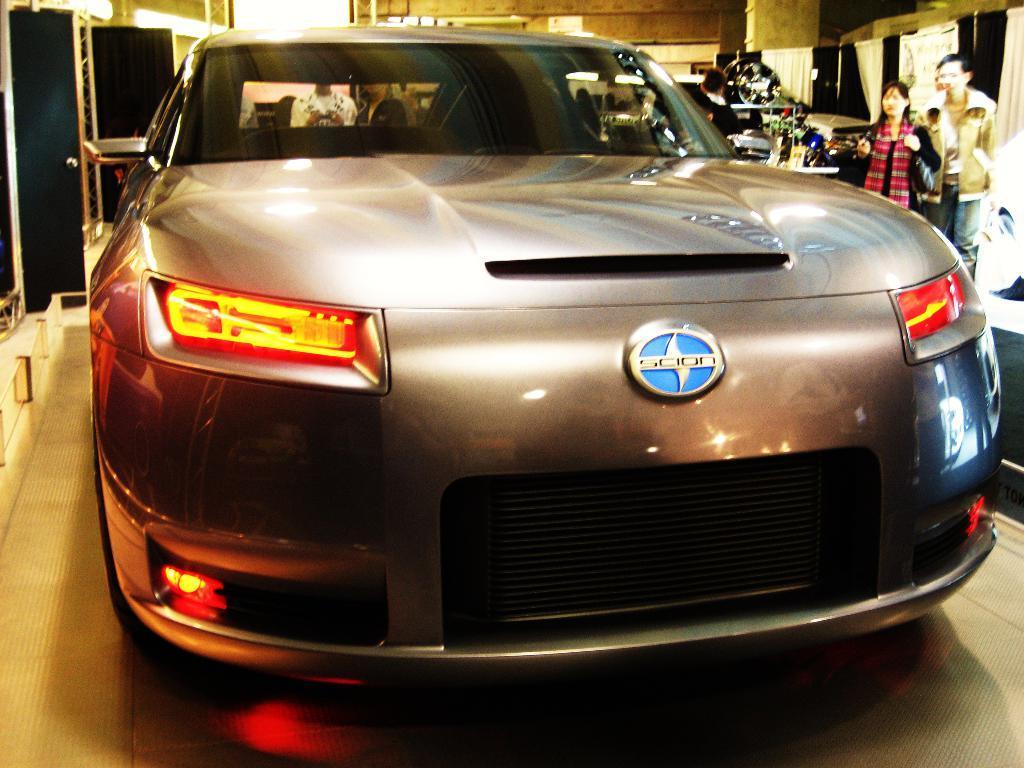Describe this image in one or two sentences. In this image I can see car which is in ash color. Back I can see few people. The car is on the brown color floor. 